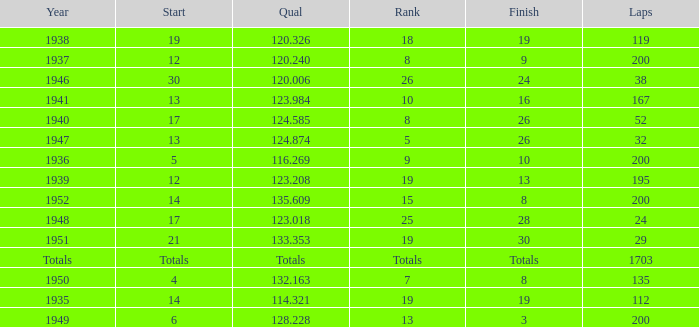In 1937, what was the finish? 9.0. 